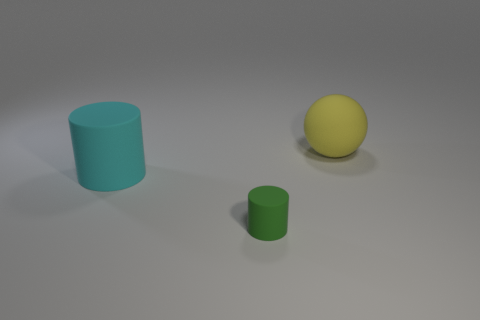Are there fewer tiny green objects than large green metallic spheres?
Make the answer very short. No. There is a thing that is to the right of the cyan matte object and on the left side of the big yellow rubber object; what is its size?
Give a very brief answer. Small. What size is the rubber object that is to the left of the rubber object in front of the cylinder that is behind the green matte cylinder?
Your response must be concise. Large. How many other things are there of the same color as the rubber sphere?
Your answer should be compact. 0. Is the color of the cylinder to the left of the green object the same as the tiny matte thing?
Your answer should be compact. No. How many objects are either green things or tiny yellow shiny cylinders?
Give a very brief answer. 1. What is the color of the big thing that is to the left of the yellow rubber ball?
Offer a terse response. Cyan. Are there fewer tiny green rubber cylinders that are to the right of the tiny green object than rubber balls?
Provide a short and direct response. Yes. Are there any other things that are the same size as the ball?
Ensure brevity in your answer.  Yes. Do the ball and the small cylinder have the same material?
Ensure brevity in your answer.  Yes. 